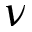Convert formula to latex. <formula><loc_0><loc_0><loc_500><loc_500>\nu</formula> 